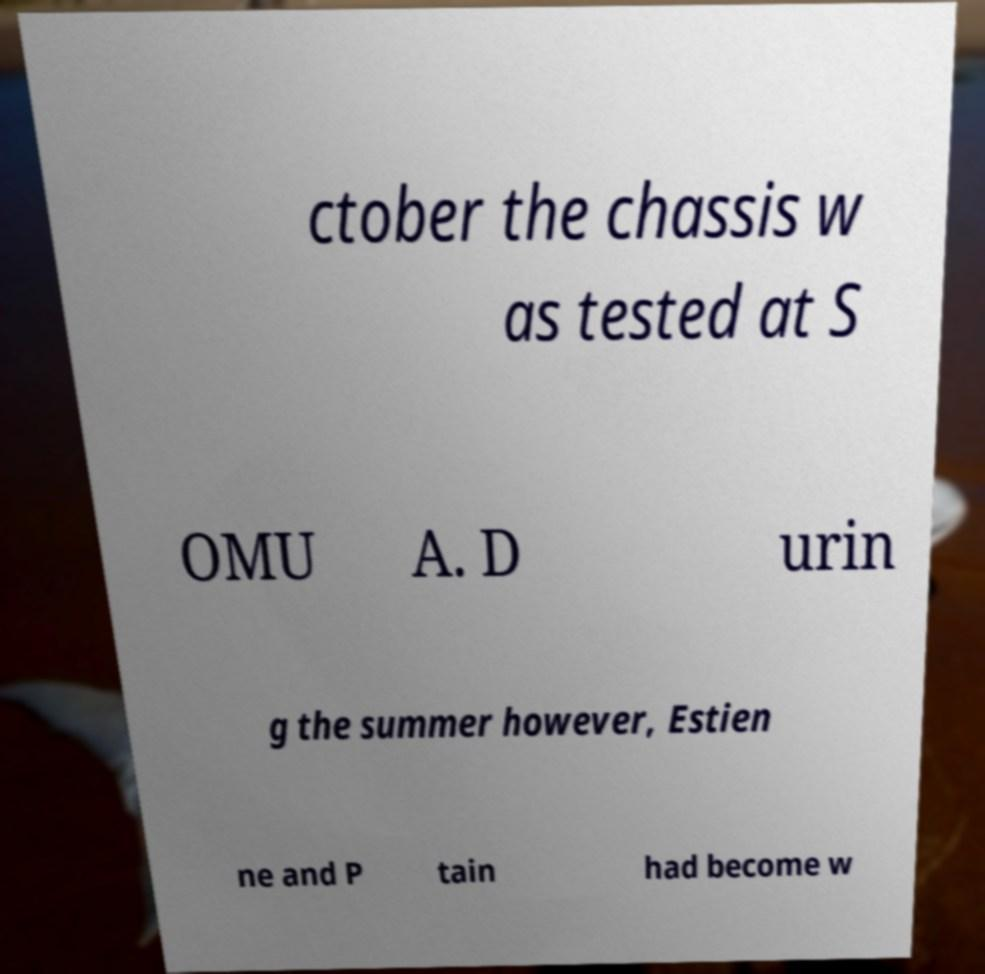Please read and relay the text visible in this image. What does it say? ctober the chassis w as tested at S OMU A. D urin g the summer however, Estien ne and P tain had become w 